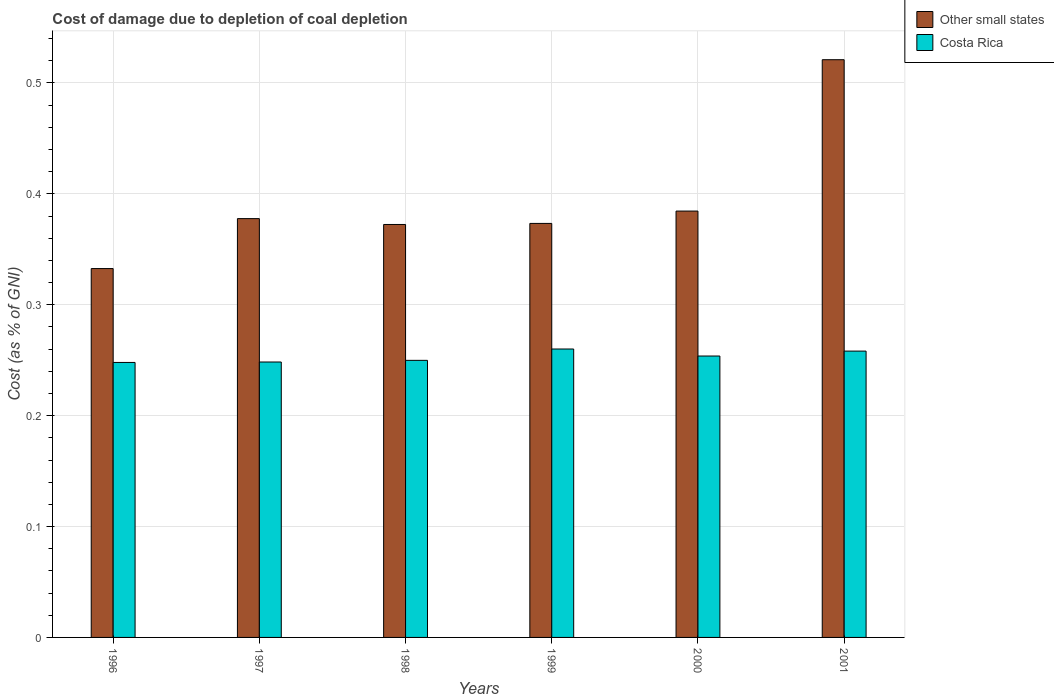How many different coloured bars are there?
Provide a succinct answer. 2. How many groups of bars are there?
Keep it short and to the point. 6. Are the number of bars per tick equal to the number of legend labels?
Your answer should be compact. Yes. Are the number of bars on each tick of the X-axis equal?
Make the answer very short. Yes. What is the label of the 5th group of bars from the left?
Ensure brevity in your answer.  2000. What is the cost of damage caused due to coal depletion in Costa Rica in 1997?
Your response must be concise. 0.25. Across all years, what is the maximum cost of damage caused due to coal depletion in Costa Rica?
Ensure brevity in your answer.  0.26. Across all years, what is the minimum cost of damage caused due to coal depletion in Costa Rica?
Offer a very short reply. 0.25. What is the total cost of damage caused due to coal depletion in Other small states in the graph?
Ensure brevity in your answer.  2.36. What is the difference between the cost of damage caused due to coal depletion in Costa Rica in 1998 and that in 1999?
Ensure brevity in your answer.  -0.01. What is the difference between the cost of damage caused due to coal depletion in Costa Rica in 1998 and the cost of damage caused due to coal depletion in Other small states in 2001?
Offer a very short reply. -0.27. What is the average cost of damage caused due to coal depletion in Costa Rica per year?
Offer a terse response. 0.25. In the year 1997, what is the difference between the cost of damage caused due to coal depletion in Costa Rica and cost of damage caused due to coal depletion in Other small states?
Give a very brief answer. -0.13. In how many years, is the cost of damage caused due to coal depletion in Costa Rica greater than 0.30000000000000004 %?
Keep it short and to the point. 0. What is the ratio of the cost of damage caused due to coal depletion in Other small states in 1997 to that in 2000?
Give a very brief answer. 0.98. What is the difference between the highest and the second highest cost of damage caused due to coal depletion in Other small states?
Provide a short and direct response. 0.14. What is the difference between the highest and the lowest cost of damage caused due to coal depletion in Costa Rica?
Your response must be concise. 0.01. In how many years, is the cost of damage caused due to coal depletion in Costa Rica greater than the average cost of damage caused due to coal depletion in Costa Rica taken over all years?
Make the answer very short. 3. What does the 1st bar from the left in 1996 represents?
Provide a succinct answer. Other small states. How many bars are there?
Provide a succinct answer. 12. Are the values on the major ticks of Y-axis written in scientific E-notation?
Provide a short and direct response. No. Does the graph contain any zero values?
Offer a very short reply. No. Where does the legend appear in the graph?
Offer a very short reply. Top right. How many legend labels are there?
Offer a very short reply. 2. How are the legend labels stacked?
Keep it short and to the point. Vertical. What is the title of the graph?
Provide a short and direct response. Cost of damage due to depletion of coal depletion. What is the label or title of the Y-axis?
Provide a succinct answer. Cost (as % of GNI). What is the Cost (as % of GNI) in Other small states in 1996?
Your response must be concise. 0.33. What is the Cost (as % of GNI) of Costa Rica in 1996?
Your answer should be very brief. 0.25. What is the Cost (as % of GNI) of Other small states in 1997?
Make the answer very short. 0.38. What is the Cost (as % of GNI) of Costa Rica in 1997?
Provide a succinct answer. 0.25. What is the Cost (as % of GNI) in Other small states in 1998?
Your answer should be very brief. 0.37. What is the Cost (as % of GNI) of Costa Rica in 1998?
Provide a succinct answer. 0.25. What is the Cost (as % of GNI) in Other small states in 1999?
Your answer should be very brief. 0.37. What is the Cost (as % of GNI) in Costa Rica in 1999?
Provide a succinct answer. 0.26. What is the Cost (as % of GNI) of Other small states in 2000?
Your answer should be compact. 0.38. What is the Cost (as % of GNI) in Costa Rica in 2000?
Offer a terse response. 0.25. What is the Cost (as % of GNI) in Other small states in 2001?
Your response must be concise. 0.52. What is the Cost (as % of GNI) of Costa Rica in 2001?
Your answer should be very brief. 0.26. Across all years, what is the maximum Cost (as % of GNI) of Other small states?
Offer a terse response. 0.52. Across all years, what is the maximum Cost (as % of GNI) of Costa Rica?
Ensure brevity in your answer.  0.26. Across all years, what is the minimum Cost (as % of GNI) in Other small states?
Ensure brevity in your answer.  0.33. Across all years, what is the minimum Cost (as % of GNI) in Costa Rica?
Offer a terse response. 0.25. What is the total Cost (as % of GNI) in Other small states in the graph?
Your answer should be very brief. 2.36. What is the total Cost (as % of GNI) of Costa Rica in the graph?
Keep it short and to the point. 1.52. What is the difference between the Cost (as % of GNI) in Other small states in 1996 and that in 1997?
Provide a succinct answer. -0.04. What is the difference between the Cost (as % of GNI) of Costa Rica in 1996 and that in 1997?
Your answer should be very brief. -0. What is the difference between the Cost (as % of GNI) of Other small states in 1996 and that in 1998?
Give a very brief answer. -0.04. What is the difference between the Cost (as % of GNI) of Costa Rica in 1996 and that in 1998?
Make the answer very short. -0. What is the difference between the Cost (as % of GNI) of Other small states in 1996 and that in 1999?
Keep it short and to the point. -0.04. What is the difference between the Cost (as % of GNI) of Costa Rica in 1996 and that in 1999?
Ensure brevity in your answer.  -0.01. What is the difference between the Cost (as % of GNI) in Other small states in 1996 and that in 2000?
Ensure brevity in your answer.  -0.05. What is the difference between the Cost (as % of GNI) of Costa Rica in 1996 and that in 2000?
Your answer should be very brief. -0.01. What is the difference between the Cost (as % of GNI) in Other small states in 1996 and that in 2001?
Your response must be concise. -0.19. What is the difference between the Cost (as % of GNI) in Costa Rica in 1996 and that in 2001?
Keep it short and to the point. -0.01. What is the difference between the Cost (as % of GNI) of Other small states in 1997 and that in 1998?
Offer a very short reply. 0.01. What is the difference between the Cost (as % of GNI) in Costa Rica in 1997 and that in 1998?
Your response must be concise. -0. What is the difference between the Cost (as % of GNI) of Other small states in 1997 and that in 1999?
Ensure brevity in your answer.  0. What is the difference between the Cost (as % of GNI) in Costa Rica in 1997 and that in 1999?
Keep it short and to the point. -0.01. What is the difference between the Cost (as % of GNI) of Other small states in 1997 and that in 2000?
Your response must be concise. -0.01. What is the difference between the Cost (as % of GNI) of Costa Rica in 1997 and that in 2000?
Your answer should be compact. -0.01. What is the difference between the Cost (as % of GNI) of Other small states in 1997 and that in 2001?
Offer a very short reply. -0.14. What is the difference between the Cost (as % of GNI) in Costa Rica in 1997 and that in 2001?
Offer a terse response. -0.01. What is the difference between the Cost (as % of GNI) of Other small states in 1998 and that in 1999?
Your answer should be very brief. -0. What is the difference between the Cost (as % of GNI) of Costa Rica in 1998 and that in 1999?
Offer a terse response. -0.01. What is the difference between the Cost (as % of GNI) in Other small states in 1998 and that in 2000?
Give a very brief answer. -0.01. What is the difference between the Cost (as % of GNI) in Costa Rica in 1998 and that in 2000?
Provide a short and direct response. -0. What is the difference between the Cost (as % of GNI) in Other small states in 1998 and that in 2001?
Provide a succinct answer. -0.15. What is the difference between the Cost (as % of GNI) in Costa Rica in 1998 and that in 2001?
Keep it short and to the point. -0.01. What is the difference between the Cost (as % of GNI) in Other small states in 1999 and that in 2000?
Keep it short and to the point. -0.01. What is the difference between the Cost (as % of GNI) of Costa Rica in 1999 and that in 2000?
Offer a terse response. 0.01. What is the difference between the Cost (as % of GNI) in Other small states in 1999 and that in 2001?
Offer a terse response. -0.15. What is the difference between the Cost (as % of GNI) in Costa Rica in 1999 and that in 2001?
Give a very brief answer. 0. What is the difference between the Cost (as % of GNI) of Other small states in 2000 and that in 2001?
Provide a short and direct response. -0.14. What is the difference between the Cost (as % of GNI) in Costa Rica in 2000 and that in 2001?
Your response must be concise. -0. What is the difference between the Cost (as % of GNI) of Other small states in 1996 and the Cost (as % of GNI) of Costa Rica in 1997?
Provide a succinct answer. 0.08. What is the difference between the Cost (as % of GNI) of Other small states in 1996 and the Cost (as % of GNI) of Costa Rica in 1998?
Provide a short and direct response. 0.08. What is the difference between the Cost (as % of GNI) in Other small states in 1996 and the Cost (as % of GNI) in Costa Rica in 1999?
Keep it short and to the point. 0.07. What is the difference between the Cost (as % of GNI) of Other small states in 1996 and the Cost (as % of GNI) of Costa Rica in 2000?
Your response must be concise. 0.08. What is the difference between the Cost (as % of GNI) of Other small states in 1996 and the Cost (as % of GNI) of Costa Rica in 2001?
Give a very brief answer. 0.07. What is the difference between the Cost (as % of GNI) in Other small states in 1997 and the Cost (as % of GNI) in Costa Rica in 1998?
Ensure brevity in your answer.  0.13. What is the difference between the Cost (as % of GNI) in Other small states in 1997 and the Cost (as % of GNI) in Costa Rica in 1999?
Offer a terse response. 0.12. What is the difference between the Cost (as % of GNI) in Other small states in 1997 and the Cost (as % of GNI) in Costa Rica in 2000?
Your response must be concise. 0.12. What is the difference between the Cost (as % of GNI) of Other small states in 1997 and the Cost (as % of GNI) of Costa Rica in 2001?
Give a very brief answer. 0.12. What is the difference between the Cost (as % of GNI) in Other small states in 1998 and the Cost (as % of GNI) in Costa Rica in 1999?
Provide a succinct answer. 0.11. What is the difference between the Cost (as % of GNI) of Other small states in 1998 and the Cost (as % of GNI) of Costa Rica in 2000?
Offer a terse response. 0.12. What is the difference between the Cost (as % of GNI) of Other small states in 1998 and the Cost (as % of GNI) of Costa Rica in 2001?
Provide a succinct answer. 0.11. What is the difference between the Cost (as % of GNI) of Other small states in 1999 and the Cost (as % of GNI) of Costa Rica in 2000?
Ensure brevity in your answer.  0.12. What is the difference between the Cost (as % of GNI) of Other small states in 1999 and the Cost (as % of GNI) of Costa Rica in 2001?
Offer a terse response. 0.12. What is the difference between the Cost (as % of GNI) in Other small states in 2000 and the Cost (as % of GNI) in Costa Rica in 2001?
Offer a very short reply. 0.13. What is the average Cost (as % of GNI) of Other small states per year?
Offer a very short reply. 0.39. What is the average Cost (as % of GNI) of Costa Rica per year?
Offer a terse response. 0.25. In the year 1996, what is the difference between the Cost (as % of GNI) of Other small states and Cost (as % of GNI) of Costa Rica?
Your answer should be very brief. 0.08. In the year 1997, what is the difference between the Cost (as % of GNI) in Other small states and Cost (as % of GNI) in Costa Rica?
Provide a short and direct response. 0.13. In the year 1998, what is the difference between the Cost (as % of GNI) in Other small states and Cost (as % of GNI) in Costa Rica?
Give a very brief answer. 0.12. In the year 1999, what is the difference between the Cost (as % of GNI) of Other small states and Cost (as % of GNI) of Costa Rica?
Offer a terse response. 0.11. In the year 2000, what is the difference between the Cost (as % of GNI) of Other small states and Cost (as % of GNI) of Costa Rica?
Make the answer very short. 0.13. In the year 2001, what is the difference between the Cost (as % of GNI) in Other small states and Cost (as % of GNI) in Costa Rica?
Your answer should be compact. 0.26. What is the ratio of the Cost (as % of GNI) of Other small states in 1996 to that in 1997?
Your response must be concise. 0.88. What is the ratio of the Cost (as % of GNI) of Other small states in 1996 to that in 1998?
Ensure brevity in your answer.  0.89. What is the ratio of the Cost (as % of GNI) in Costa Rica in 1996 to that in 1998?
Provide a succinct answer. 0.99. What is the ratio of the Cost (as % of GNI) in Other small states in 1996 to that in 1999?
Your answer should be very brief. 0.89. What is the ratio of the Cost (as % of GNI) of Costa Rica in 1996 to that in 1999?
Your answer should be very brief. 0.95. What is the ratio of the Cost (as % of GNI) in Other small states in 1996 to that in 2000?
Your answer should be compact. 0.87. What is the ratio of the Cost (as % of GNI) of Costa Rica in 1996 to that in 2000?
Keep it short and to the point. 0.98. What is the ratio of the Cost (as % of GNI) of Other small states in 1996 to that in 2001?
Offer a very short reply. 0.64. What is the ratio of the Cost (as % of GNI) in Costa Rica in 1996 to that in 2001?
Provide a succinct answer. 0.96. What is the ratio of the Cost (as % of GNI) in Other small states in 1997 to that in 1998?
Keep it short and to the point. 1.01. What is the ratio of the Cost (as % of GNI) of Costa Rica in 1997 to that in 1998?
Your answer should be compact. 0.99. What is the ratio of the Cost (as % of GNI) in Other small states in 1997 to that in 1999?
Provide a succinct answer. 1.01. What is the ratio of the Cost (as % of GNI) in Costa Rica in 1997 to that in 1999?
Provide a short and direct response. 0.95. What is the ratio of the Cost (as % of GNI) in Other small states in 1997 to that in 2000?
Give a very brief answer. 0.98. What is the ratio of the Cost (as % of GNI) in Costa Rica in 1997 to that in 2000?
Offer a terse response. 0.98. What is the ratio of the Cost (as % of GNI) in Other small states in 1997 to that in 2001?
Provide a succinct answer. 0.72. What is the ratio of the Cost (as % of GNI) in Costa Rica in 1997 to that in 2001?
Provide a short and direct response. 0.96. What is the ratio of the Cost (as % of GNI) of Costa Rica in 1998 to that in 1999?
Offer a terse response. 0.96. What is the ratio of the Cost (as % of GNI) in Other small states in 1998 to that in 2000?
Make the answer very short. 0.97. What is the ratio of the Cost (as % of GNI) of Costa Rica in 1998 to that in 2000?
Make the answer very short. 0.98. What is the ratio of the Cost (as % of GNI) in Other small states in 1998 to that in 2001?
Ensure brevity in your answer.  0.71. What is the ratio of the Cost (as % of GNI) of Costa Rica in 1998 to that in 2001?
Your response must be concise. 0.97. What is the ratio of the Cost (as % of GNI) of Other small states in 1999 to that in 2001?
Ensure brevity in your answer.  0.72. What is the ratio of the Cost (as % of GNI) in Costa Rica in 1999 to that in 2001?
Offer a very short reply. 1.01. What is the ratio of the Cost (as % of GNI) in Other small states in 2000 to that in 2001?
Your response must be concise. 0.74. What is the ratio of the Cost (as % of GNI) of Costa Rica in 2000 to that in 2001?
Make the answer very short. 0.98. What is the difference between the highest and the second highest Cost (as % of GNI) of Other small states?
Ensure brevity in your answer.  0.14. What is the difference between the highest and the second highest Cost (as % of GNI) of Costa Rica?
Your answer should be compact. 0. What is the difference between the highest and the lowest Cost (as % of GNI) in Other small states?
Give a very brief answer. 0.19. What is the difference between the highest and the lowest Cost (as % of GNI) of Costa Rica?
Your answer should be compact. 0.01. 